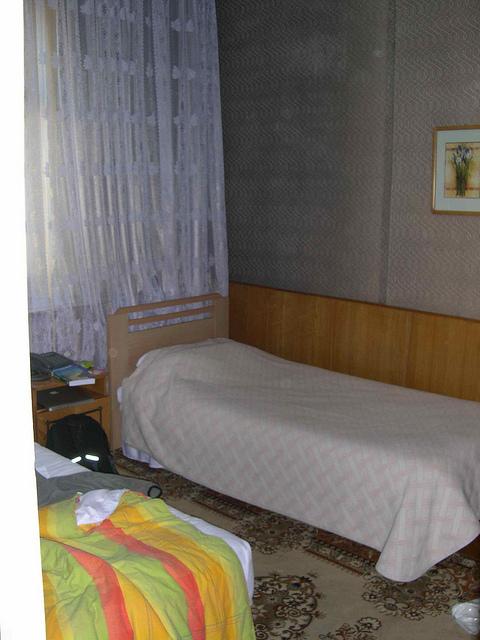Is the bed messy?
Answer briefly. No. What size is the bed?
Write a very short answer. Twin. What size is the mattress?
Write a very short answer. Twin. Does this room have any wall hangings?
Write a very short answer. Yes. What is the striped thing?
Quick response, please. Blanket. 